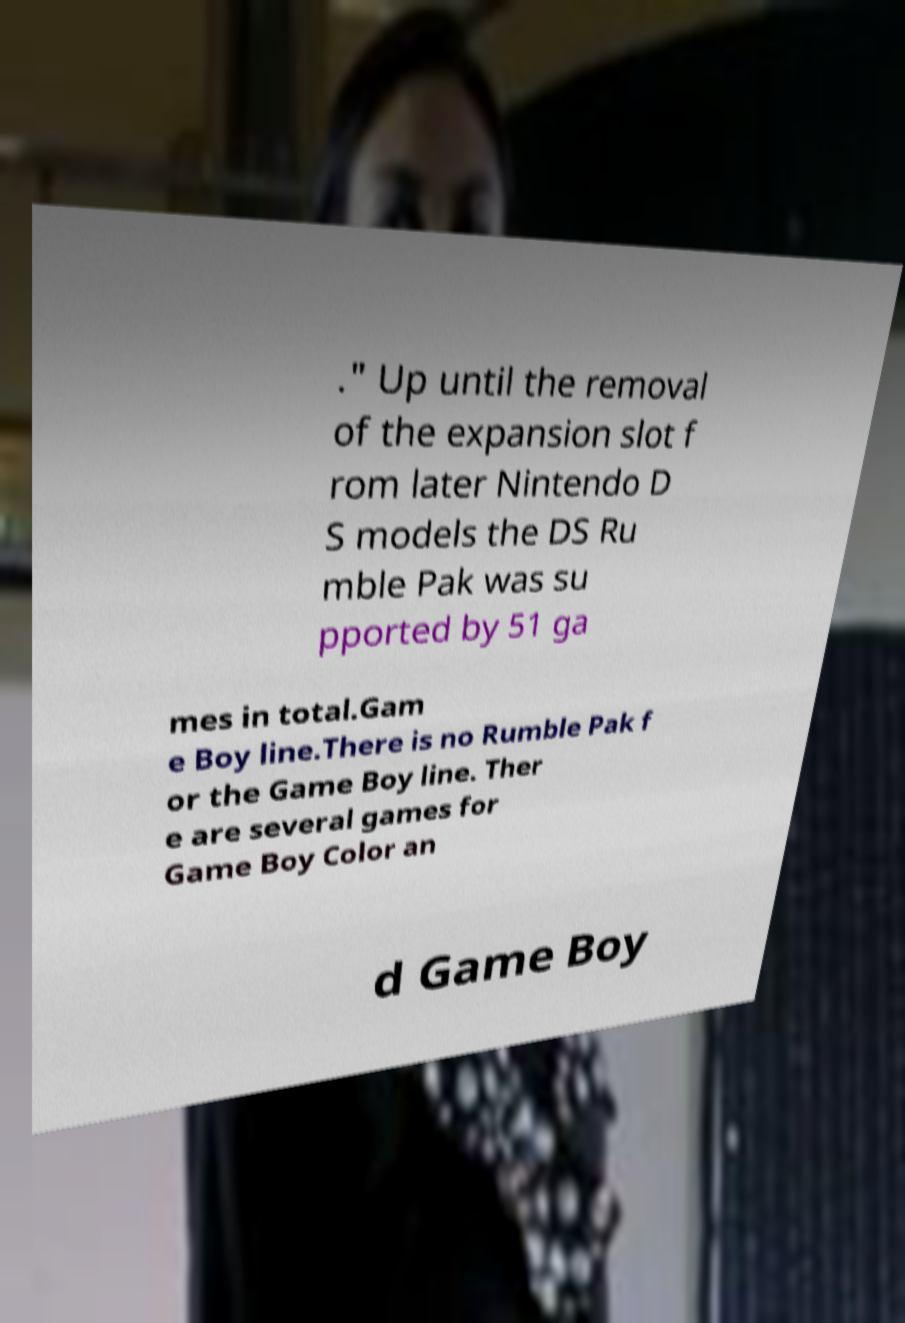I need the written content from this picture converted into text. Can you do that? ." Up until the removal of the expansion slot f rom later Nintendo D S models the DS Ru mble Pak was su pported by 51 ga mes in total.Gam e Boy line.There is no Rumble Pak f or the Game Boy line. Ther e are several games for Game Boy Color an d Game Boy 